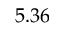Convert formula to latex. <formula><loc_0><loc_0><loc_500><loc_500>5 . 3 6</formula> 